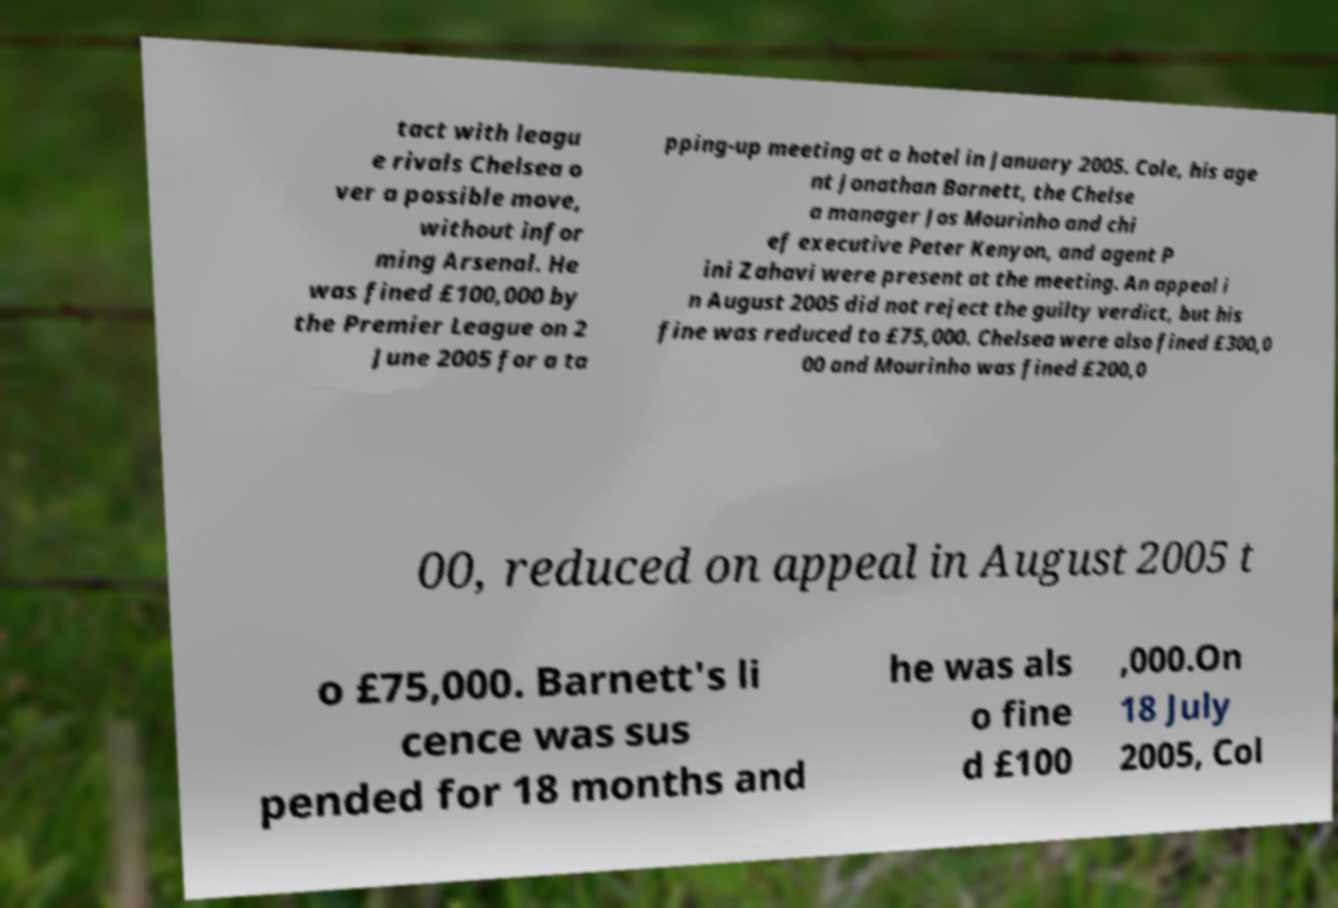There's text embedded in this image that I need extracted. Can you transcribe it verbatim? tact with leagu e rivals Chelsea o ver a possible move, without infor ming Arsenal. He was fined £100,000 by the Premier League on 2 June 2005 for a ta pping-up meeting at a hotel in January 2005. Cole, his age nt Jonathan Barnett, the Chelse a manager Jos Mourinho and chi ef executive Peter Kenyon, and agent P ini Zahavi were present at the meeting. An appeal i n August 2005 did not reject the guilty verdict, but his fine was reduced to £75,000. Chelsea were also fined £300,0 00 and Mourinho was fined £200,0 00, reduced on appeal in August 2005 t o £75,000. Barnett's li cence was sus pended for 18 months and he was als o fine d £100 ,000.On 18 July 2005, Col 